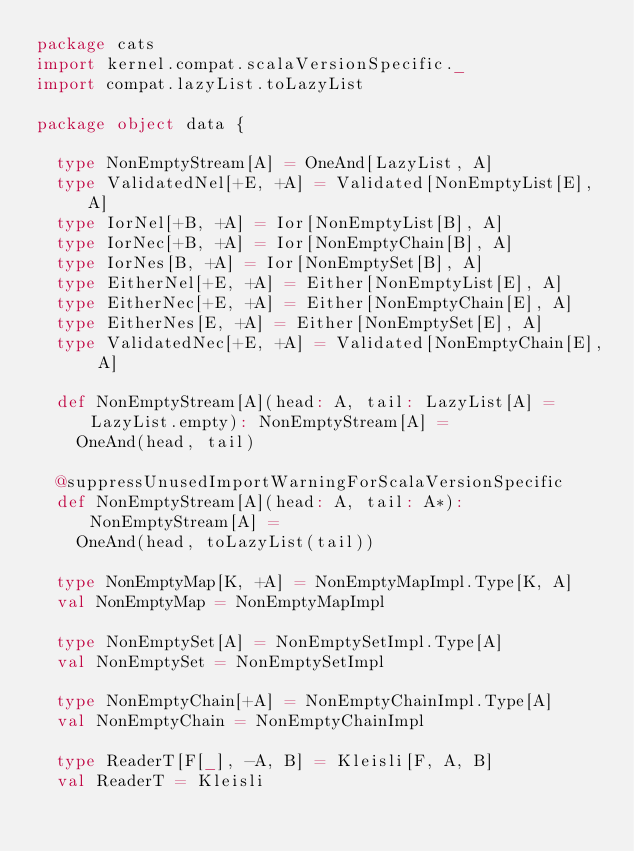<code> <loc_0><loc_0><loc_500><loc_500><_Scala_>package cats
import kernel.compat.scalaVersionSpecific._
import compat.lazyList.toLazyList

package object data {

  type NonEmptyStream[A] = OneAnd[LazyList, A]
  type ValidatedNel[+E, +A] = Validated[NonEmptyList[E], A]
  type IorNel[+B, +A] = Ior[NonEmptyList[B], A]
  type IorNec[+B, +A] = Ior[NonEmptyChain[B], A]
  type IorNes[B, +A] = Ior[NonEmptySet[B], A]
  type EitherNel[+E, +A] = Either[NonEmptyList[E], A]
  type EitherNec[+E, +A] = Either[NonEmptyChain[E], A]
  type EitherNes[E, +A] = Either[NonEmptySet[E], A]
  type ValidatedNec[+E, +A] = Validated[NonEmptyChain[E], A]

  def NonEmptyStream[A](head: A, tail: LazyList[A] = LazyList.empty): NonEmptyStream[A] =
    OneAnd(head, tail)

  @suppressUnusedImportWarningForScalaVersionSpecific
  def NonEmptyStream[A](head: A, tail: A*): NonEmptyStream[A] =
    OneAnd(head, toLazyList(tail))

  type NonEmptyMap[K, +A] = NonEmptyMapImpl.Type[K, A]
  val NonEmptyMap = NonEmptyMapImpl

  type NonEmptySet[A] = NonEmptySetImpl.Type[A]
  val NonEmptySet = NonEmptySetImpl

  type NonEmptyChain[+A] = NonEmptyChainImpl.Type[A]
  val NonEmptyChain = NonEmptyChainImpl

  type ReaderT[F[_], -A, B] = Kleisli[F, A, B]
  val ReaderT = Kleisli
</code> 